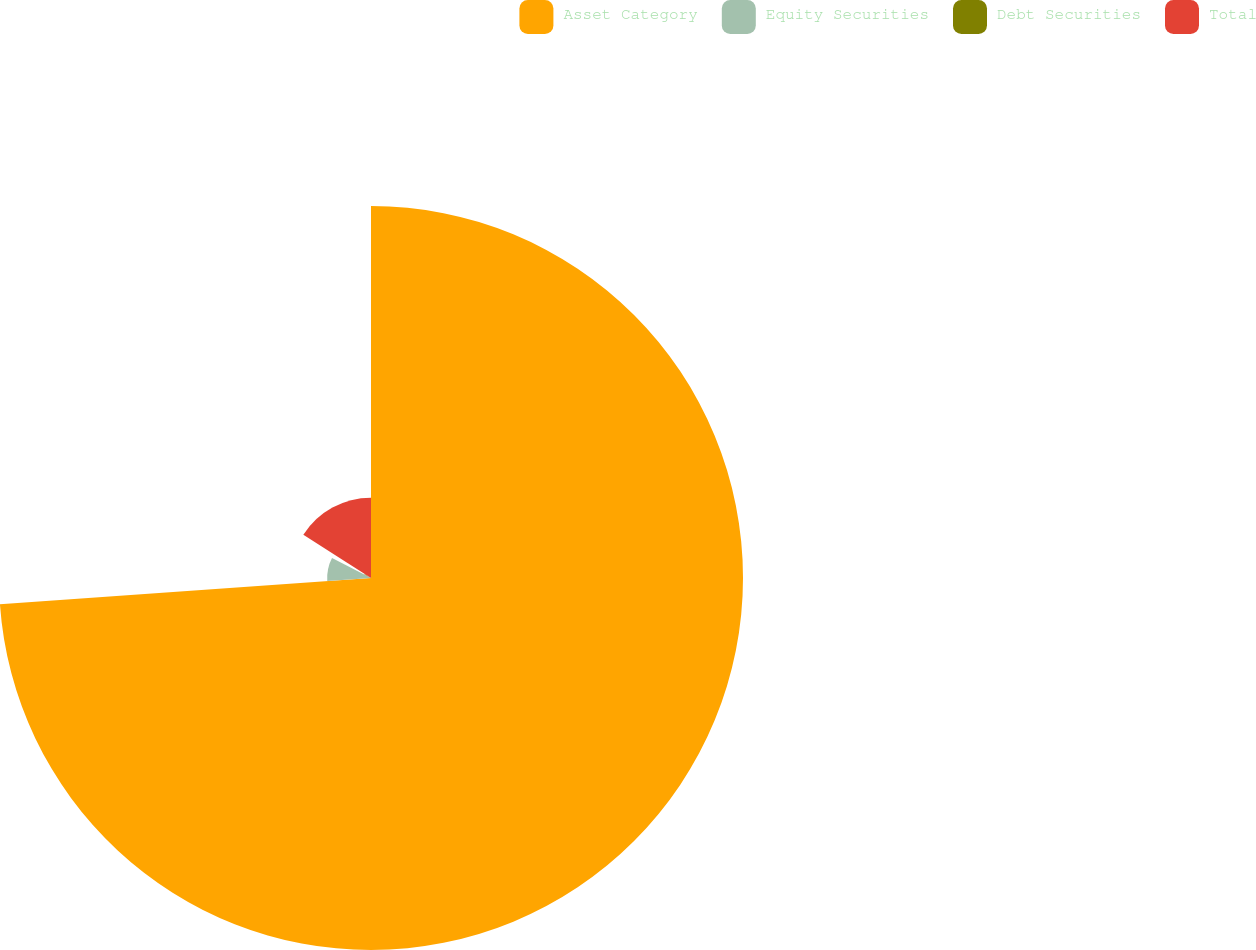Convert chart. <chart><loc_0><loc_0><loc_500><loc_500><pie_chart><fcel>Asset Category<fcel>Equity Securities<fcel>Debt Securities<fcel>Total<nl><fcel>73.88%<fcel>8.71%<fcel>1.47%<fcel>15.95%<nl></chart> 